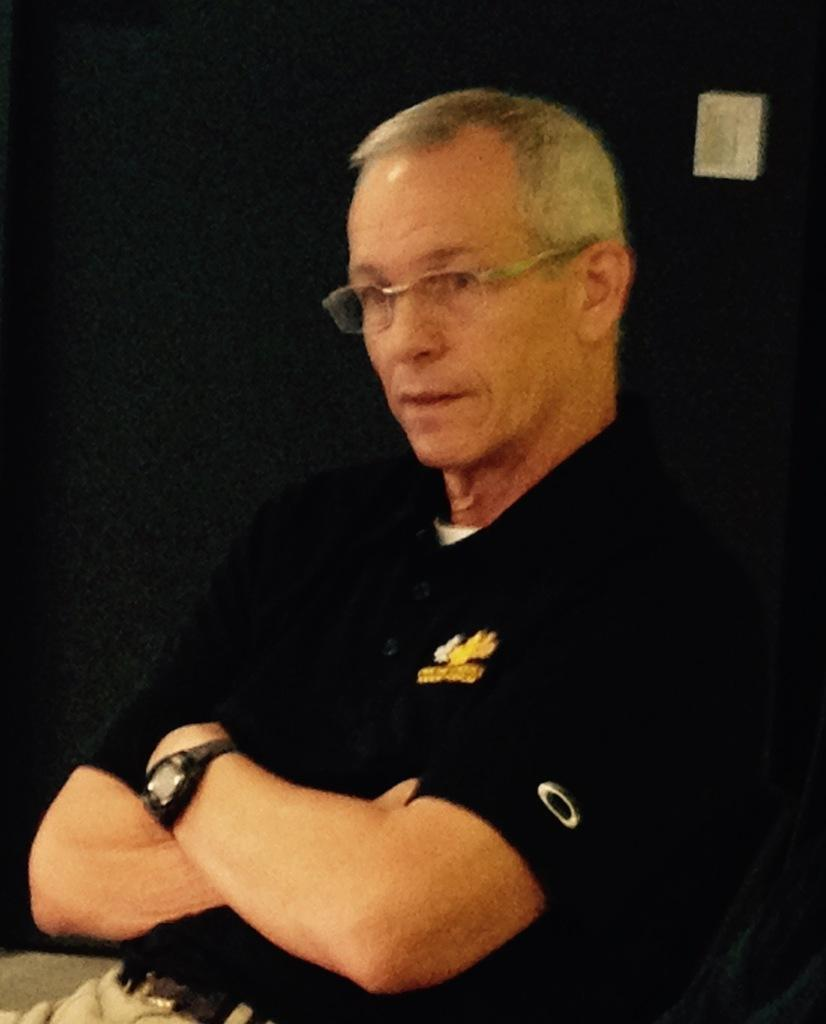Who is present in the image? There is a person in the image. What is the person wearing on their upper body? The person is wearing a black T-shirt. What accessory can be seen on the person's wrist? The person is wearing a watch. What type of eyewear is the person wearing? The person is wearing glasses (specs). What type of birds are involved in the argument in the image? There are no birds or arguments present in the image; it features a person wearing a black T-shirt, a watch, and glasses. 